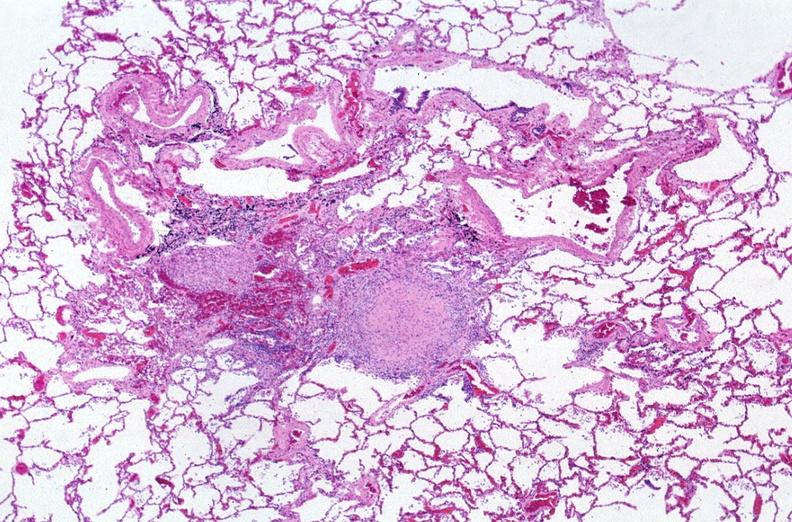does this image show lung, mycobacterium tuberculosis, granulomas and giant cells?
Answer the question using a single word or phrase. Yes 